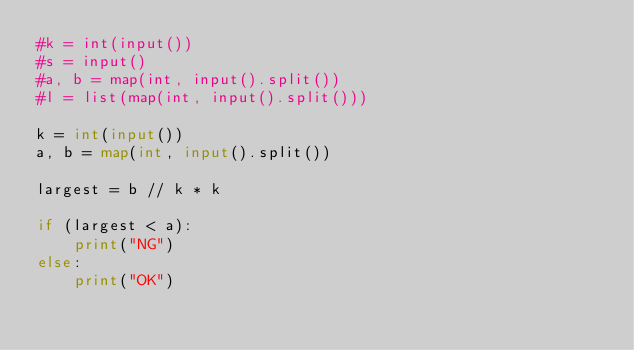Convert code to text. <code><loc_0><loc_0><loc_500><loc_500><_Python_>#k = int(input())
#s = input()
#a, b = map(int, input().split())
#l = list(map(int, input().split()))

k = int(input())
a, b = map(int, input().split())

largest = b // k * k

if (largest < a):
    print("NG")
else:
    print("OK")
</code> 